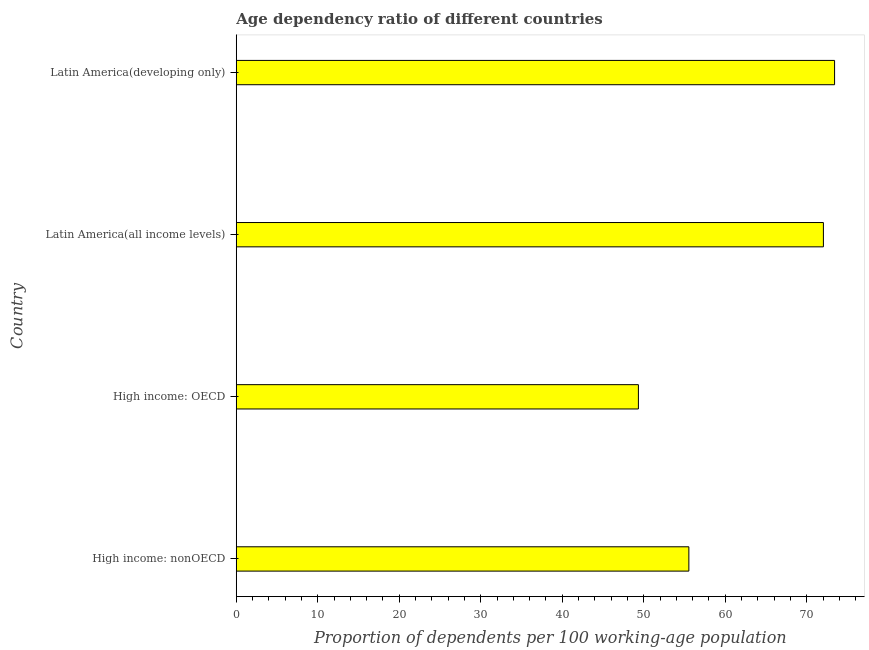Does the graph contain any zero values?
Ensure brevity in your answer.  No. What is the title of the graph?
Offer a very short reply. Age dependency ratio of different countries. What is the label or title of the X-axis?
Ensure brevity in your answer.  Proportion of dependents per 100 working-age population. What is the label or title of the Y-axis?
Offer a terse response. Country. What is the age dependency ratio in Latin America(all income levels)?
Your answer should be compact. 72.04. Across all countries, what is the maximum age dependency ratio?
Make the answer very short. 73.41. Across all countries, what is the minimum age dependency ratio?
Your response must be concise. 49.34. In which country was the age dependency ratio maximum?
Offer a terse response. Latin America(developing only). In which country was the age dependency ratio minimum?
Provide a short and direct response. High income: OECD. What is the sum of the age dependency ratio?
Ensure brevity in your answer.  250.33. What is the difference between the age dependency ratio in High income: OECD and Latin America(all income levels)?
Make the answer very short. -22.7. What is the average age dependency ratio per country?
Offer a terse response. 62.58. What is the median age dependency ratio?
Your answer should be very brief. 63.79. In how many countries, is the age dependency ratio greater than 64 ?
Your response must be concise. 2. What is the ratio of the age dependency ratio in High income: nonOECD to that in Latin America(developing only)?
Your answer should be compact. 0.76. Is the difference between the age dependency ratio in High income: OECD and Latin America(developing only) greater than the difference between any two countries?
Your response must be concise. Yes. What is the difference between the highest and the second highest age dependency ratio?
Your response must be concise. 1.37. What is the difference between the highest and the lowest age dependency ratio?
Provide a short and direct response. 24.07. How many bars are there?
Ensure brevity in your answer.  4. How many countries are there in the graph?
Your answer should be very brief. 4. Are the values on the major ticks of X-axis written in scientific E-notation?
Provide a short and direct response. No. What is the Proportion of dependents per 100 working-age population in High income: nonOECD?
Ensure brevity in your answer.  55.53. What is the Proportion of dependents per 100 working-age population in High income: OECD?
Offer a terse response. 49.34. What is the Proportion of dependents per 100 working-age population in Latin America(all income levels)?
Make the answer very short. 72.04. What is the Proportion of dependents per 100 working-age population of Latin America(developing only)?
Keep it short and to the point. 73.41. What is the difference between the Proportion of dependents per 100 working-age population in High income: nonOECD and High income: OECD?
Your response must be concise. 6.19. What is the difference between the Proportion of dependents per 100 working-age population in High income: nonOECD and Latin America(all income levels)?
Offer a terse response. -16.51. What is the difference between the Proportion of dependents per 100 working-age population in High income: nonOECD and Latin America(developing only)?
Make the answer very short. -17.88. What is the difference between the Proportion of dependents per 100 working-age population in High income: OECD and Latin America(all income levels)?
Provide a succinct answer. -22.7. What is the difference between the Proportion of dependents per 100 working-age population in High income: OECD and Latin America(developing only)?
Provide a short and direct response. -24.07. What is the difference between the Proportion of dependents per 100 working-age population in Latin America(all income levels) and Latin America(developing only)?
Ensure brevity in your answer.  -1.37. What is the ratio of the Proportion of dependents per 100 working-age population in High income: nonOECD to that in High income: OECD?
Make the answer very short. 1.12. What is the ratio of the Proportion of dependents per 100 working-age population in High income: nonOECD to that in Latin America(all income levels)?
Your answer should be very brief. 0.77. What is the ratio of the Proportion of dependents per 100 working-age population in High income: nonOECD to that in Latin America(developing only)?
Provide a succinct answer. 0.76. What is the ratio of the Proportion of dependents per 100 working-age population in High income: OECD to that in Latin America(all income levels)?
Provide a short and direct response. 0.69. What is the ratio of the Proportion of dependents per 100 working-age population in High income: OECD to that in Latin America(developing only)?
Offer a very short reply. 0.67. What is the ratio of the Proportion of dependents per 100 working-age population in Latin America(all income levels) to that in Latin America(developing only)?
Offer a terse response. 0.98. 